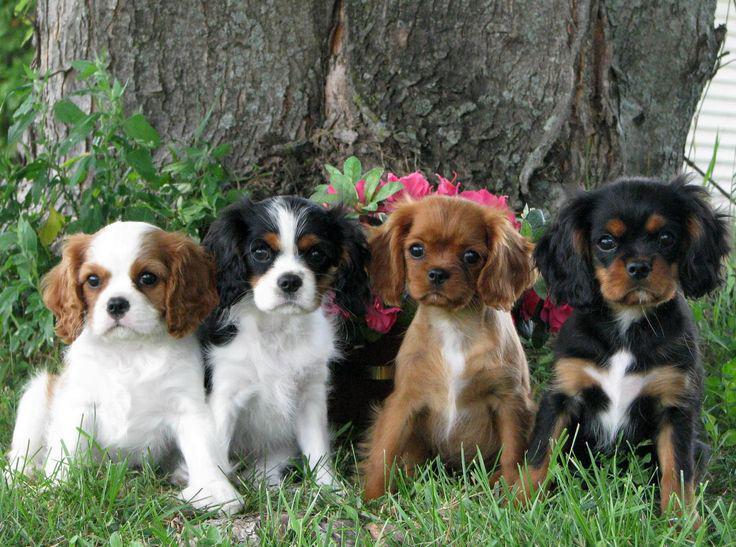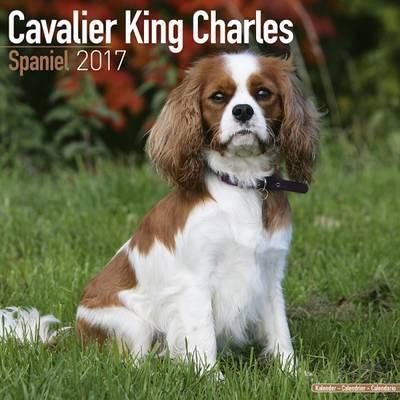The first image is the image on the left, the second image is the image on the right. Considering the images on both sides, is "There are more dogs in the right-hand image than the left." valid? Answer yes or no. No. 